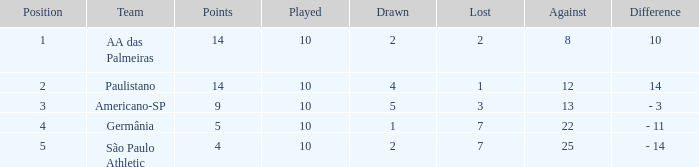What team has an against more than 8, lost of 7, and the position is 5? São Paulo Athletic. 